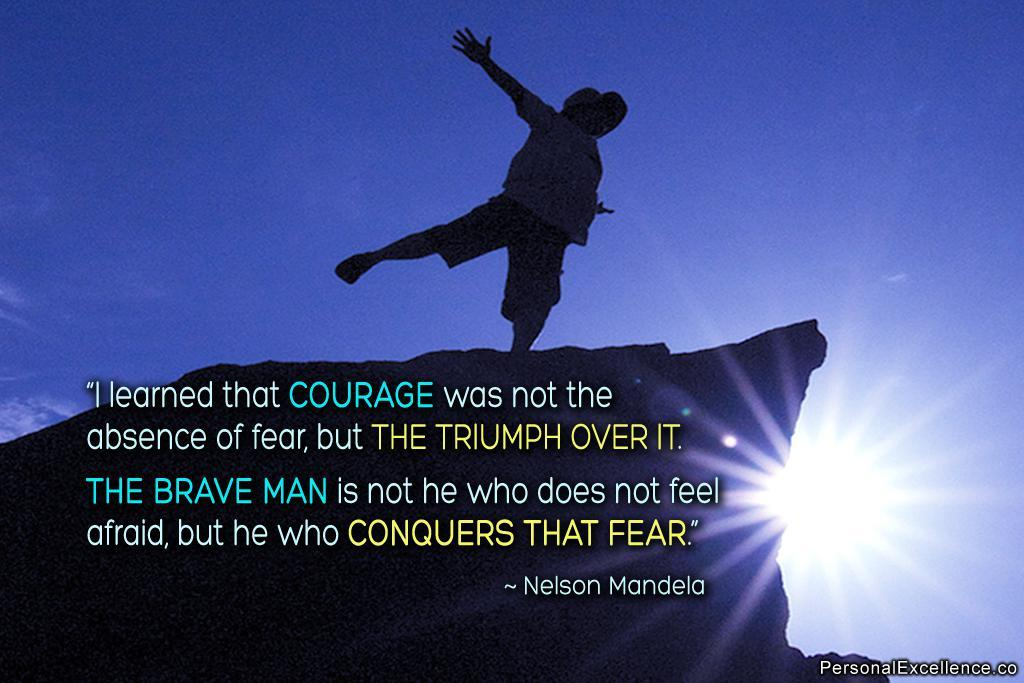What is the person in the image doing? The person is on a rock in the image. What can be seen in the sky in the image? The sun and sky are visible in the image. Is there any text present in the image? Yes, there is text present in the image. What type of skirt is the cactus wearing in the image? There is no cactus or skirt present in the image. 